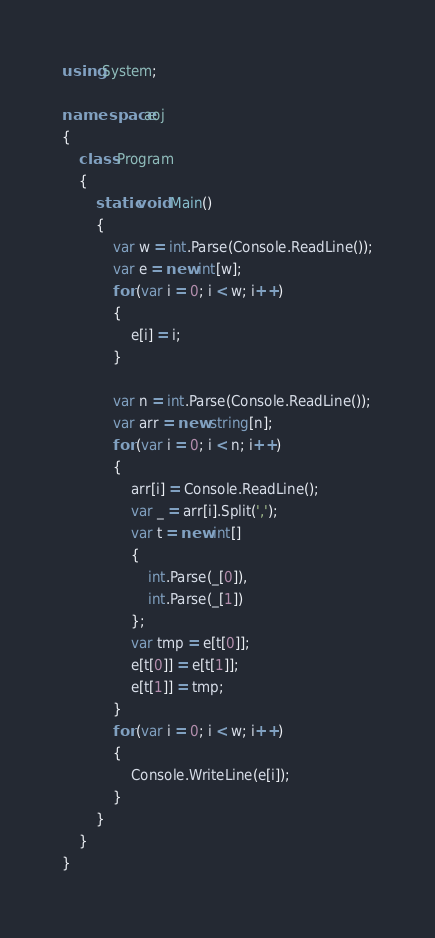<code> <loc_0><loc_0><loc_500><loc_500><_C#_>using System;

namespace aoj
{
    class Program
    {
        static void Main()
        {
            var w = int.Parse(Console.ReadLine());
            var e = new int[w];
            for (var i = 0; i < w; i++)
            {
                e[i] = i;
            }

            var n = int.Parse(Console.ReadLine());
            var arr = new string[n];
            for (var i = 0; i < n; i++)
            {
                arr[i] = Console.ReadLine();
                var _ = arr[i].Split(',');
                var t = new int[]
                {
                    int.Parse(_[0]),
                    int.Parse(_[1])
                };
                var tmp = e[t[0]];
                e[t[0]] = e[t[1]];
                e[t[1]] = tmp;
            }
            for (var i = 0; i < w; i++)
            {
                Console.WriteLine(e[i]);
            }
        }
    }
}</code> 